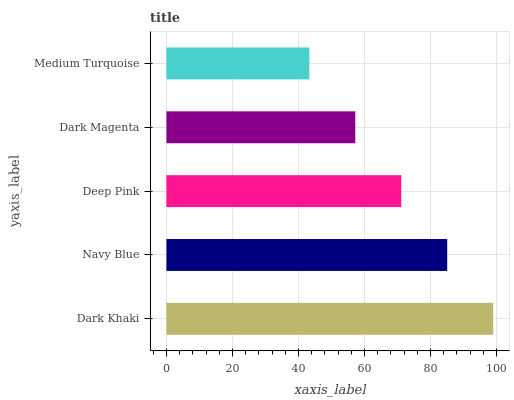Is Medium Turquoise the minimum?
Answer yes or no. Yes. Is Dark Khaki the maximum?
Answer yes or no. Yes. Is Navy Blue the minimum?
Answer yes or no. No. Is Navy Blue the maximum?
Answer yes or no. No. Is Dark Khaki greater than Navy Blue?
Answer yes or no. Yes. Is Navy Blue less than Dark Khaki?
Answer yes or no. Yes. Is Navy Blue greater than Dark Khaki?
Answer yes or no. No. Is Dark Khaki less than Navy Blue?
Answer yes or no. No. Is Deep Pink the high median?
Answer yes or no. Yes. Is Deep Pink the low median?
Answer yes or no. Yes. Is Dark Khaki the high median?
Answer yes or no. No. Is Navy Blue the low median?
Answer yes or no. No. 